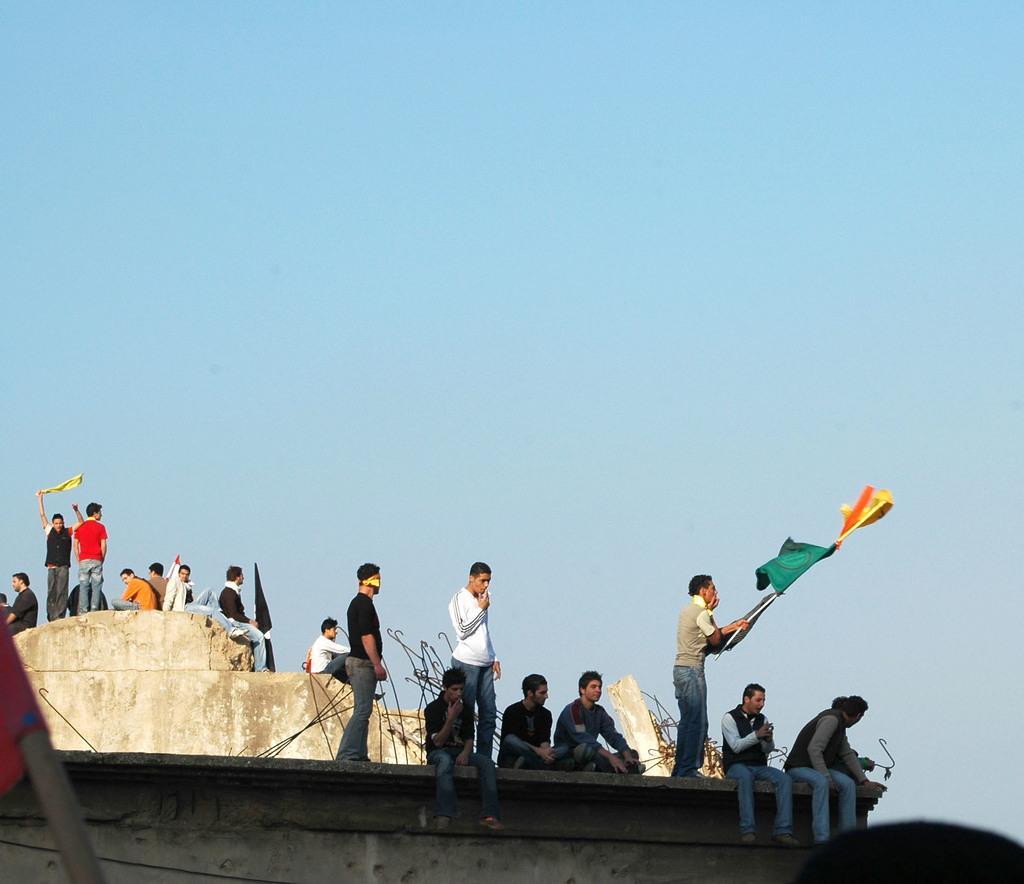In one or two sentences, can you explain what this image depicts? In this image we can see some people sitting on the wall. The wall is covered with some rods. On the left side we can see some people holding the flags and standing. 